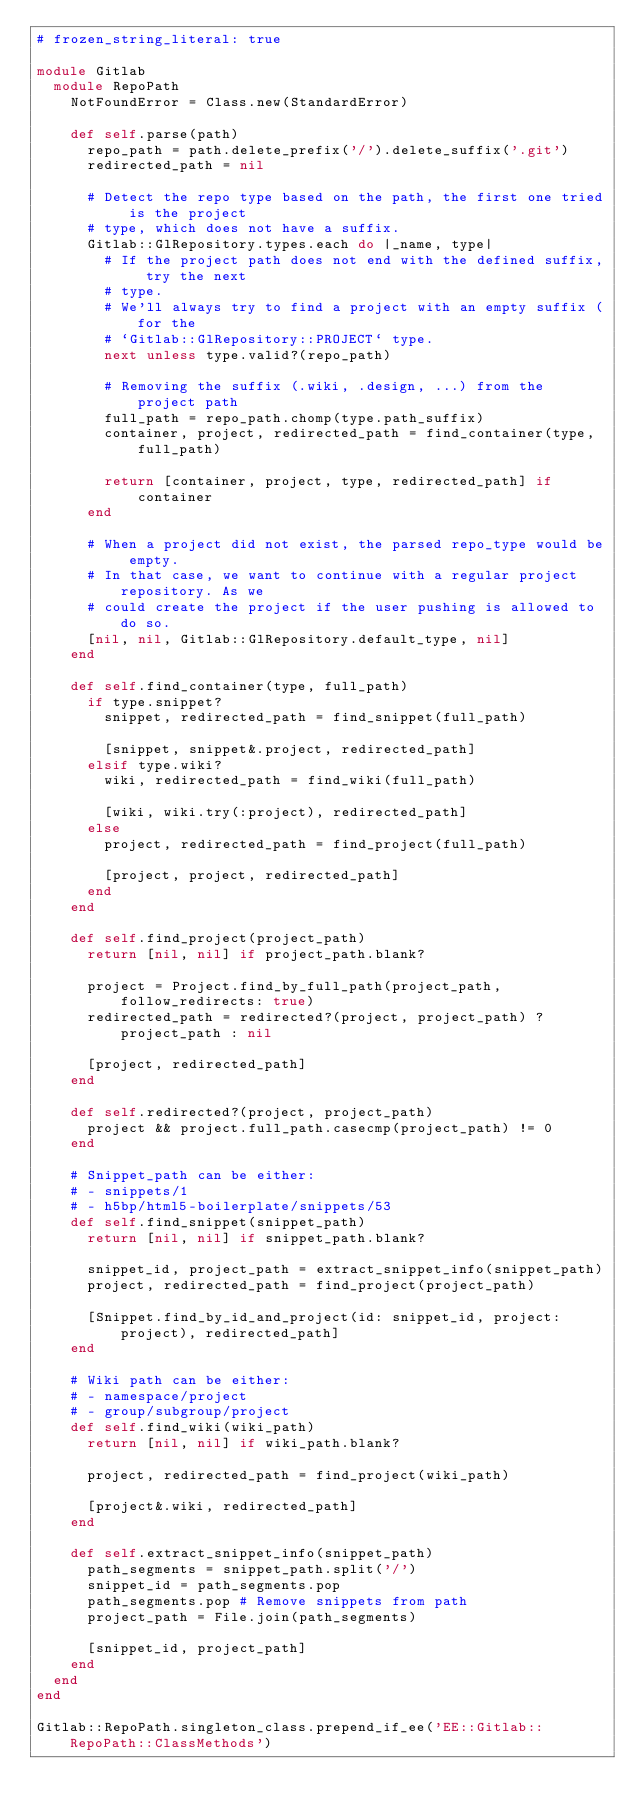Convert code to text. <code><loc_0><loc_0><loc_500><loc_500><_Ruby_># frozen_string_literal: true

module Gitlab
  module RepoPath
    NotFoundError = Class.new(StandardError)

    def self.parse(path)
      repo_path = path.delete_prefix('/').delete_suffix('.git')
      redirected_path = nil

      # Detect the repo type based on the path, the first one tried is the project
      # type, which does not have a suffix.
      Gitlab::GlRepository.types.each do |_name, type|
        # If the project path does not end with the defined suffix, try the next
        # type.
        # We'll always try to find a project with an empty suffix (for the
        # `Gitlab::GlRepository::PROJECT` type.
        next unless type.valid?(repo_path)

        # Removing the suffix (.wiki, .design, ...) from the project path
        full_path = repo_path.chomp(type.path_suffix)
        container, project, redirected_path = find_container(type, full_path)

        return [container, project, type, redirected_path] if container
      end

      # When a project did not exist, the parsed repo_type would be empty.
      # In that case, we want to continue with a regular project repository. As we
      # could create the project if the user pushing is allowed to do so.
      [nil, nil, Gitlab::GlRepository.default_type, nil]
    end

    def self.find_container(type, full_path)
      if type.snippet?
        snippet, redirected_path = find_snippet(full_path)

        [snippet, snippet&.project, redirected_path]
      elsif type.wiki?
        wiki, redirected_path = find_wiki(full_path)

        [wiki, wiki.try(:project), redirected_path]
      else
        project, redirected_path = find_project(full_path)

        [project, project, redirected_path]
      end
    end

    def self.find_project(project_path)
      return [nil, nil] if project_path.blank?

      project = Project.find_by_full_path(project_path, follow_redirects: true)
      redirected_path = redirected?(project, project_path) ? project_path : nil

      [project, redirected_path]
    end

    def self.redirected?(project, project_path)
      project && project.full_path.casecmp(project_path) != 0
    end

    # Snippet_path can be either:
    # - snippets/1
    # - h5bp/html5-boilerplate/snippets/53
    def self.find_snippet(snippet_path)
      return [nil, nil] if snippet_path.blank?

      snippet_id, project_path = extract_snippet_info(snippet_path)
      project, redirected_path = find_project(project_path)

      [Snippet.find_by_id_and_project(id: snippet_id, project: project), redirected_path]
    end

    # Wiki path can be either:
    # - namespace/project
    # - group/subgroup/project
    def self.find_wiki(wiki_path)
      return [nil, nil] if wiki_path.blank?

      project, redirected_path = find_project(wiki_path)

      [project&.wiki, redirected_path]
    end

    def self.extract_snippet_info(snippet_path)
      path_segments = snippet_path.split('/')
      snippet_id = path_segments.pop
      path_segments.pop # Remove snippets from path
      project_path = File.join(path_segments)

      [snippet_id, project_path]
    end
  end
end

Gitlab::RepoPath.singleton_class.prepend_if_ee('EE::Gitlab::RepoPath::ClassMethods')
</code> 